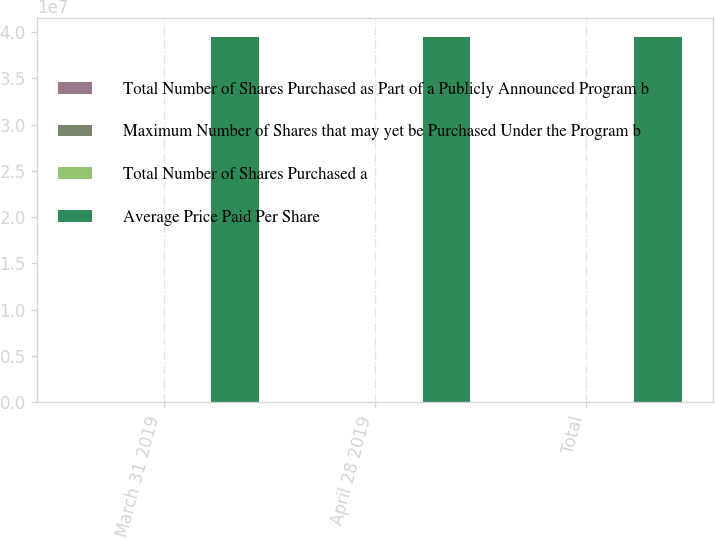Convert chart to OTSL. <chart><loc_0><loc_0><loc_500><loc_500><stacked_bar_chart><ecel><fcel>March 31 2019<fcel>April 28 2019<fcel>Total<nl><fcel>Total Number of Shares Purchased as Part of a Publicly Announced Program b<fcel>250<fcel>8032<fcel>8282<nl><fcel>Maximum Number of Shares that may yet be Purchased Under the Program b<fcel>47.22<fcel>50.99<fcel>50.88<nl><fcel>Total Number of Shares Purchased a<fcel>250<fcel>8032<fcel>8282<nl><fcel>Average Price Paid Per Share<fcel>3.94986e+07<fcel>3.94906e+07<fcel>3.94906e+07<nl></chart> 